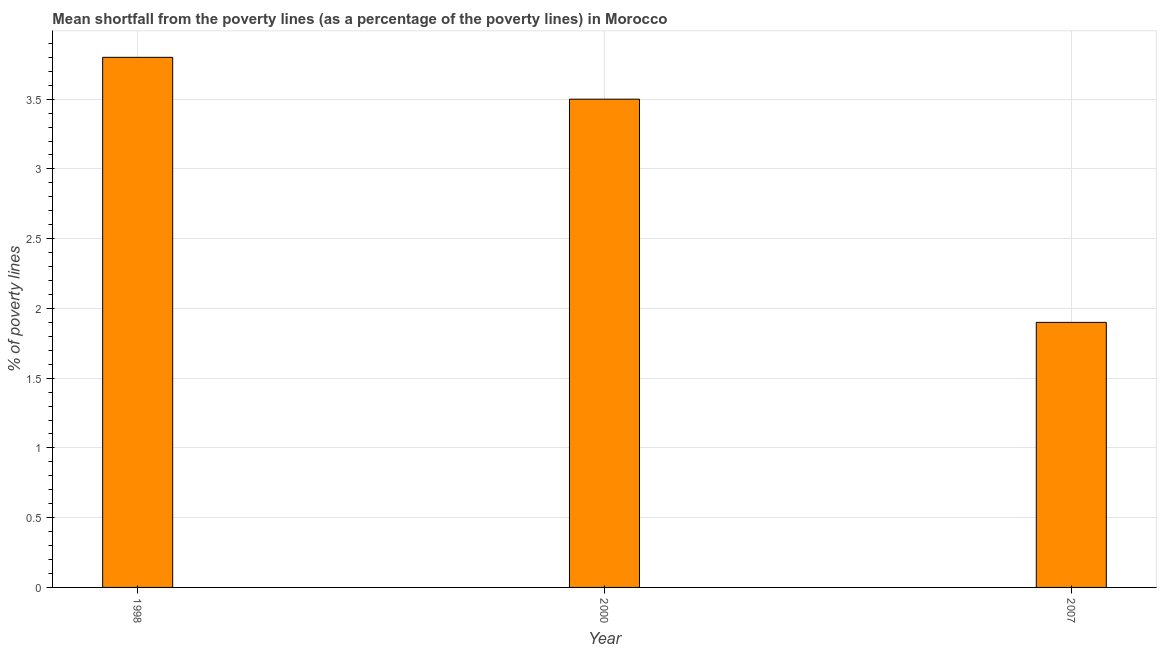What is the title of the graph?
Keep it short and to the point. Mean shortfall from the poverty lines (as a percentage of the poverty lines) in Morocco. What is the label or title of the Y-axis?
Provide a succinct answer. % of poverty lines. Across all years, what is the minimum poverty gap at national poverty lines?
Offer a terse response. 1.9. In which year was the poverty gap at national poverty lines minimum?
Offer a very short reply. 2007. What is the difference between the poverty gap at national poverty lines in 1998 and 2000?
Your answer should be compact. 0.3. What is the average poverty gap at national poverty lines per year?
Provide a succinct answer. 3.07. In how many years, is the poverty gap at national poverty lines greater than 1.6 %?
Offer a terse response. 3. Is the poverty gap at national poverty lines in 1998 less than that in 2007?
Offer a very short reply. No. Is the difference between the poverty gap at national poverty lines in 2000 and 2007 greater than the difference between any two years?
Ensure brevity in your answer.  No. Is the sum of the poverty gap at national poverty lines in 1998 and 2007 greater than the maximum poverty gap at national poverty lines across all years?
Offer a terse response. Yes. What is the difference between the highest and the lowest poverty gap at national poverty lines?
Make the answer very short. 1.9. Are all the bars in the graph horizontal?
Your response must be concise. No. How many years are there in the graph?
Your answer should be very brief. 3. What is the difference between two consecutive major ticks on the Y-axis?
Give a very brief answer. 0.5. What is the % of poverty lines of 2007?
Your answer should be very brief. 1.9. What is the difference between the % of poverty lines in 1998 and 2000?
Your response must be concise. 0.3. What is the difference between the % of poverty lines in 1998 and 2007?
Provide a succinct answer. 1.9. What is the ratio of the % of poverty lines in 1998 to that in 2000?
Provide a short and direct response. 1.09. What is the ratio of the % of poverty lines in 1998 to that in 2007?
Your answer should be very brief. 2. What is the ratio of the % of poverty lines in 2000 to that in 2007?
Give a very brief answer. 1.84. 